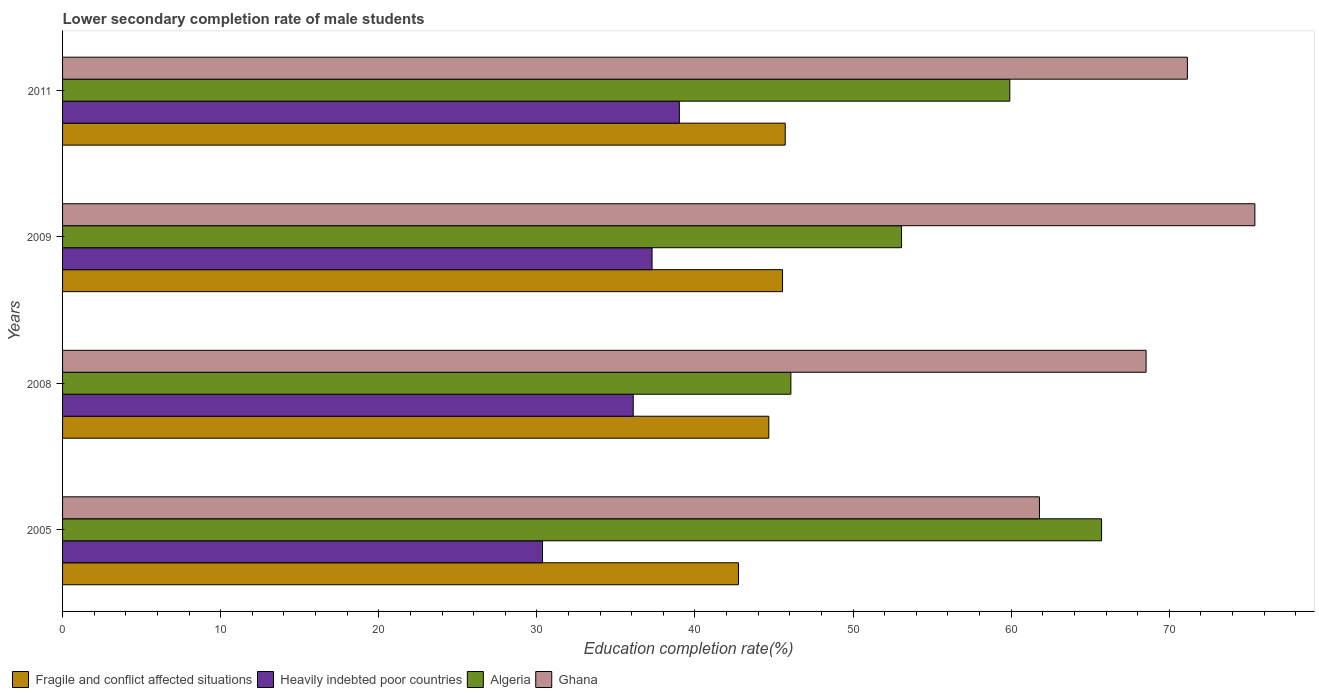How many different coloured bars are there?
Offer a terse response. 4. How many groups of bars are there?
Your answer should be very brief. 4. Are the number of bars per tick equal to the number of legend labels?
Make the answer very short. Yes. Are the number of bars on each tick of the Y-axis equal?
Ensure brevity in your answer.  Yes. How many bars are there on the 2nd tick from the top?
Give a very brief answer. 4. In how many cases, is the number of bars for a given year not equal to the number of legend labels?
Make the answer very short. 0. What is the lower secondary completion rate of male students in Fragile and conflict affected situations in 2005?
Offer a terse response. 42.75. Across all years, what is the maximum lower secondary completion rate of male students in Fragile and conflict affected situations?
Ensure brevity in your answer.  45.71. Across all years, what is the minimum lower secondary completion rate of male students in Algeria?
Offer a very short reply. 46.07. In which year was the lower secondary completion rate of male students in Heavily indebted poor countries minimum?
Provide a short and direct response. 2005. What is the total lower secondary completion rate of male students in Ghana in the graph?
Offer a very short reply. 276.88. What is the difference between the lower secondary completion rate of male students in Algeria in 2005 and that in 2008?
Your answer should be compact. 19.65. What is the difference between the lower secondary completion rate of male students in Heavily indebted poor countries in 2009 and the lower secondary completion rate of male students in Ghana in 2008?
Keep it short and to the point. -31.25. What is the average lower secondary completion rate of male students in Ghana per year?
Offer a very short reply. 69.22. In the year 2008, what is the difference between the lower secondary completion rate of male students in Algeria and lower secondary completion rate of male students in Fragile and conflict affected situations?
Offer a terse response. 1.4. What is the ratio of the lower secondary completion rate of male students in Heavily indebted poor countries in 2009 to that in 2011?
Your answer should be compact. 0.96. Is the lower secondary completion rate of male students in Fragile and conflict affected situations in 2005 less than that in 2009?
Give a very brief answer. Yes. Is the difference between the lower secondary completion rate of male students in Algeria in 2005 and 2009 greater than the difference between the lower secondary completion rate of male students in Fragile and conflict affected situations in 2005 and 2009?
Offer a terse response. Yes. What is the difference between the highest and the second highest lower secondary completion rate of male students in Fragile and conflict affected situations?
Offer a very short reply. 0.17. What is the difference between the highest and the lowest lower secondary completion rate of male students in Heavily indebted poor countries?
Your answer should be compact. 8.66. In how many years, is the lower secondary completion rate of male students in Fragile and conflict affected situations greater than the average lower secondary completion rate of male students in Fragile and conflict affected situations taken over all years?
Ensure brevity in your answer.  3. Is the sum of the lower secondary completion rate of male students in Heavily indebted poor countries in 2005 and 2008 greater than the maximum lower secondary completion rate of male students in Algeria across all years?
Your answer should be compact. Yes. Is it the case that in every year, the sum of the lower secondary completion rate of male students in Algeria and lower secondary completion rate of male students in Heavily indebted poor countries is greater than the sum of lower secondary completion rate of male students in Fragile and conflict affected situations and lower secondary completion rate of male students in Ghana?
Give a very brief answer. No. What does the 1st bar from the top in 2008 represents?
Keep it short and to the point. Ghana. What does the 3rd bar from the bottom in 2011 represents?
Make the answer very short. Algeria. How many bars are there?
Provide a succinct answer. 16. Does the graph contain grids?
Make the answer very short. No. Where does the legend appear in the graph?
Provide a short and direct response. Bottom left. How many legend labels are there?
Provide a short and direct response. 4. What is the title of the graph?
Your response must be concise. Lower secondary completion rate of male students. Does "Honduras" appear as one of the legend labels in the graph?
Give a very brief answer. No. What is the label or title of the X-axis?
Your answer should be very brief. Education completion rate(%). What is the Education completion rate(%) of Fragile and conflict affected situations in 2005?
Give a very brief answer. 42.75. What is the Education completion rate(%) in Heavily indebted poor countries in 2005?
Your answer should be compact. 30.36. What is the Education completion rate(%) of Algeria in 2005?
Your answer should be compact. 65.72. What is the Education completion rate(%) of Ghana in 2005?
Give a very brief answer. 61.79. What is the Education completion rate(%) of Fragile and conflict affected situations in 2008?
Your answer should be compact. 44.67. What is the Education completion rate(%) of Heavily indebted poor countries in 2008?
Give a very brief answer. 36.09. What is the Education completion rate(%) in Algeria in 2008?
Your answer should be very brief. 46.07. What is the Education completion rate(%) of Ghana in 2008?
Give a very brief answer. 68.53. What is the Education completion rate(%) in Fragile and conflict affected situations in 2009?
Offer a very short reply. 45.54. What is the Education completion rate(%) in Heavily indebted poor countries in 2009?
Make the answer very short. 37.29. What is the Education completion rate(%) of Algeria in 2009?
Your answer should be compact. 53.06. What is the Education completion rate(%) of Ghana in 2009?
Give a very brief answer. 75.41. What is the Education completion rate(%) of Fragile and conflict affected situations in 2011?
Give a very brief answer. 45.71. What is the Education completion rate(%) of Heavily indebted poor countries in 2011?
Your response must be concise. 39.01. What is the Education completion rate(%) of Algeria in 2011?
Provide a succinct answer. 59.91. What is the Education completion rate(%) of Ghana in 2011?
Provide a short and direct response. 71.14. Across all years, what is the maximum Education completion rate(%) in Fragile and conflict affected situations?
Your response must be concise. 45.71. Across all years, what is the maximum Education completion rate(%) of Heavily indebted poor countries?
Provide a short and direct response. 39.01. Across all years, what is the maximum Education completion rate(%) of Algeria?
Make the answer very short. 65.72. Across all years, what is the maximum Education completion rate(%) of Ghana?
Provide a short and direct response. 75.41. Across all years, what is the minimum Education completion rate(%) of Fragile and conflict affected situations?
Keep it short and to the point. 42.75. Across all years, what is the minimum Education completion rate(%) in Heavily indebted poor countries?
Your answer should be compact. 30.36. Across all years, what is the minimum Education completion rate(%) in Algeria?
Provide a succinct answer. 46.07. Across all years, what is the minimum Education completion rate(%) in Ghana?
Your response must be concise. 61.79. What is the total Education completion rate(%) in Fragile and conflict affected situations in the graph?
Provide a short and direct response. 178.66. What is the total Education completion rate(%) of Heavily indebted poor countries in the graph?
Your response must be concise. 142.75. What is the total Education completion rate(%) in Algeria in the graph?
Your answer should be compact. 224.76. What is the total Education completion rate(%) in Ghana in the graph?
Provide a succinct answer. 276.88. What is the difference between the Education completion rate(%) of Fragile and conflict affected situations in 2005 and that in 2008?
Provide a short and direct response. -1.92. What is the difference between the Education completion rate(%) in Heavily indebted poor countries in 2005 and that in 2008?
Your answer should be very brief. -5.74. What is the difference between the Education completion rate(%) of Algeria in 2005 and that in 2008?
Ensure brevity in your answer.  19.65. What is the difference between the Education completion rate(%) of Ghana in 2005 and that in 2008?
Offer a very short reply. -6.74. What is the difference between the Education completion rate(%) in Fragile and conflict affected situations in 2005 and that in 2009?
Your answer should be compact. -2.79. What is the difference between the Education completion rate(%) of Heavily indebted poor countries in 2005 and that in 2009?
Your response must be concise. -6.93. What is the difference between the Education completion rate(%) in Algeria in 2005 and that in 2009?
Provide a succinct answer. 12.65. What is the difference between the Education completion rate(%) of Ghana in 2005 and that in 2009?
Your answer should be very brief. -13.62. What is the difference between the Education completion rate(%) of Fragile and conflict affected situations in 2005 and that in 2011?
Make the answer very short. -2.96. What is the difference between the Education completion rate(%) in Heavily indebted poor countries in 2005 and that in 2011?
Your answer should be compact. -8.66. What is the difference between the Education completion rate(%) of Algeria in 2005 and that in 2011?
Provide a succinct answer. 5.8. What is the difference between the Education completion rate(%) of Ghana in 2005 and that in 2011?
Offer a very short reply. -9.36. What is the difference between the Education completion rate(%) in Fragile and conflict affected situations in 2008 and that in 2009?
Ensure brevity in your answer.  -0.87. What is the difference between the Education completion rate(%) of Heavily indebted poor countries in 2008 and that in 2009?
Offer a terse response. -1.19. What is the difference between the Education completion rate(%) of Algeria in 2008 and that in 2009?
Provide a succinct answer. -7. What is the difference between the Education completion rate(%) in Ghana in 2008 and that in 2009?
Your answer should be compact. -6.88. What is the difference between the Education completion rate(%) of Fragile and conflict affected situations in 2008 and that in 2011?
Provide a succinct answer. -1.04. What is the difference between the Education completion rate(%) in Heavily indebted poor countries in 2008 and that in 2011?
Provide a short and direct response. -2.92. What is the difference between the Education completion rate(%) in Algeria in 2008 and that in 2011?
Your response must be concise. -13.85. What is the difference between the Education completion rate(%) of Ghana in 2008 and that in 2011?
Offer a very short reply. -2.61. What is the difference between the Education completion rate(%) in Fragile and conflict affected situations in 2009 and that in 2011?
Keep it short and to the point. -0.17. What is the difference between the Education completion rate(%) in Heavily indebted poor countries in 2009 and that in 2011?
Provide a succinct answer. -1.73. What is the difference between the Education completion rate(%) of Algeria in 2009 and that in 2011?
Offer a very short reply. -6.85. What is the difference between the Education completion rate(%) of Ghana in 2009 and that in 2011?
Your answer should be compact. 4.27. What is the difference between the Education completion rate(%) in Fragile and conflict affected situations in 2005 and the Education completion rate(%) in Heavily indebted poor countries in 2008?
Provide a succinct answer. 6.66. What is the difference between the Education completion rate(%) in Fragile and conflict affected situations in 2005 and the Education completion rate(%) in Algeria in 2008?
Provide a short and direct response. -3.32. What is the difference between the Education completion rate(%) of Fragile and conflict affected situations in 2005 and the Education completion rate(%) of Ghana in 2008?
Provide a short and direct response. -25.78. What is the difference between the Education completion rate(%) of Heavily indebted poor countries in 2005 and the Education completion rate(%) of Algeria in 2008?
Give a very brief answer. -15.71. What is the difference between the Education completion rate(%) in Heavily indebted poor countries in 2005 and the Education completion rate(%) in Ghana in 2008?
Offer a terse response. -38.17. What is the difference between the Education completion rate(%) of Algeria in 2005 and the Education completion rate(%) of Ghana in 2008?
Ensure brevity in your answer.  -2.82. What is the difference between the Education completion rate(%) in Fragile and conflict affected situations in 2005 and the Education completion rate(%) in Heavily indebted poor countries in 2009?
Your answer should be very brief. 5.46. What is the difference between the Education completion rate(%) of Fragile and conflict affected situations in 2005 and the Education completion rate(%) of Algeria in 2009?
Ensure brevity in your answer.  -10.31. What is the difference between the Education completion rate(%) of Fragile and conflict affected situations in 2005 and the Education completion rate(%) of Ghana in 2009?
Keep it short and to the point. -32.66. What is the difference between the Education completion rate(%) in Heavily indebted poor countries in 2005 and the Education completion rate(%) in Algeria in 2009?
Your answer should be compact. -22.71. What is the difference between the Education completion rate(%) in Heavily indebted poor countries in 2005 and the Education completion rate(%) in Ghana in 2009?
Your answer should be compact. -45.06. What is the difference between the Education completion rate(%) in Algeria in 2005 and the Education completion rate(%) in Ghana in 2009?
Provide a succinct answer. -9.7. What is the difference between the Education completion rate(%) in Fragile and conflict affected situations in 2005 and the Education completion rate(%) in Heavily indebted poor countries in 2011?
Your answer should be compact. 3.74. What is the difference between the Education completion rate(%) of Fragile and conflict affected situations in 2005 and the Education completion rate(%) of Algeria in 2011?
Offer a terse response. -17.16. What is the difference between the Education completion rate(%) in Fragile and conflict affected situations in 2005 and the Education completion rate(%) in Ghana in 2011?
Your answer should be compact. -28.39. What is the difference between the Education completion rate(%) in Heavily indebted poor countries in 2005 and the Education completion rate(%) in Algeria in 2011?
Keep it short and to the point. -29.56. What is the difference between the Education completion rate(%) in Heavily indebted poor countries in 2005 and the Education completion rate(%) in Ghana in 2011?
Give a very brief answer. -40.79. What is the difference between the Education completion rate(%) of Algeria in 2005 and the Education completion rate(%) of Ghana in 2011?
Offer a terse response. -5.43. What is the difference between the Education completion rate(%) of Fragile and conflict affected situations in 2008 and the Education completion rate(%) of Heavily indebted poor countries in 2009?
Provide a succinct answer. 7.38. What is the difference between the Education completion rate(%) of Fragile and conflict affected situations in 2008 and the Education completion rate(%) of Algeria in 2009?
Provide a short and direct response. -8.4. What is the difference between the Education completion rate(%) in Fragile and conflict affected situations in 2008 and the Education completion rate(%) in Ghana in 2009?
Your answer should be very brief. -30.74. What is the difference between the Education completion rate(%) of Heavily indebted poor countries in 2008 and the Education completion rate(%) of Algeria in 2009?
Offer a terse response. -16.97. What is the difference between the Education completion rate(%) of Heavily indebted poor countries in 2008 and the Education completion rate(%) of Ghana in 2009?
Provide a succinct answer. -39.32. What is the difference between the Education completion rate(%) of Algeria in 2008 and the Education completion rate(%) of Ghana in 2009?
Your answer should be compact. -29.35. What is the difference between the Education completion rate(%) in Fragile and conflict affected situations in 2008 and the Education completion rate(%) in Heavily indebted poor countries in 2011?
Your response must be concise. 5.66. What is the difference between the Education completion rate(%) in Fragile and conflict affected situations in 2008 and the Education completion rate(%) in Algeria in 2011?
Your response must be concise. -15.24. What is the difference between the Education completion rate(%) in Fragile and conflict affected situations in 2008 and the Education completion rate(%) in Ghana in 2011?
Keep it short and to the point. -26.48. What is the difference between the Education completion rate(%) in Heavily indebted poor countries in 2008 and the Education completion rate(%) in Algeria in 2011?
Provide a succinct answer. -23.82. What is the difference between the Education completion rate(%) in Heavily indebted poor countries in 2008 and the Education completion rate(%) in Ghana in 2011?
Your answer should be very brief. -35.05. What is the difference between the Education completion rate(%) of Algeria in 2008 and the Education completion rate(%) of Ghana in 2011?
Provide a succinct answer. -25.08. What is the difference between the Education completion rate(%) in Fragile and conflict affected situations in 2009 and the Education completion rate(%) in Heavily indebted poor countries in 2011?
Provide a succinct answer. 6.53. What is the difference between the Education completion rate(%) in Fragile and conflict affected situations in 2009 and the Education completion rate(%) in Algeria in 2011?
Provide a short and direct response. -14.37. What is the difference between the Education completion rate(%) of Fragile and conflict affected situations in 2009 and the Education completion rate(%) of Ghana in 2011?
Provide a short and direct response. -25.61. What is the difference between the Education completion rate(%) in Heavily indebted poor countries in 2009 and the Education completion rate(%) in Algeria in 2011?
Offer a terse response. -22.63. What is the difference between the Education completion rate(%) in Heavily indebted poor countries in 2009 and the Education completion rate(%) in Ghana in 2011?
Provide a short and direct response. -33.86. What is the difference between the Education completion rate(%) in Algeria in 2009 and the Education completion rate(%) in Ghana in 2011?
Make the answer very short. -18.08. What is the average Education completion rate(%) in Fragile and conflict affected situations per year?
Provide a succinct answer. 44.67. What is the average Education completion rate(%) in Heavily indebted poor countries per year?
Your response must be concise. 35.69. What is the average Education completion rate(%) of Algeria per year?
Ensure brevity in your answer.  56.19. What is the average Education completion rate(%) in Ghana per year?
Keep it short and to the point. 69.22. In the year 2005, what is the difference between the Education completion rate(%) in Fragile and conflict affected situations and Education completion rate(%) in Heavily indebted poor countries?
Your answer should be very brief. 12.39. In the year 2005, what is the difference between the Education completion rate(%) in Fragile and conflict affected situations and Education completion rate(%) in Algeria?
Make the answer very short. -22.97. In the year 2005, what is the difference between the Education completion rate(%) in Fragile and conflict affected situations and Education completion rate(%) in Ghana?
Ensure brevity in your answer.  -19.04. In the year 2005, what is the difference between the Education completion rate(%) in Heavily indebted poor countries and Education completion rate(%) in Algeria?
Your answer should be very brief. -35.36. In the year 2005, what is the difference between the Education completion rate(%) in Heavily indebted poor countries and Education completion rate(%) in Ghana?
Provide a succinct answer. -31.43. In the year 2005, what is the difference between the Education completion rate(%) of Algeria and Education completion rate(%) of Ghana?
Your answer should be very brief. 3.93. In the year 2008, what is the difference between the Education completion rate(%) in Fragile and conflict affected situations and Education completion rate(%) in Heavily indebted poor countries?
Ensure brevity in your answer.  8.57. In the year 2008, what is the difference between the Education completion rate(%) of Fragile and conflict affected situations and Education completion rate(%) of Algeria?
Your answer should be very brief. -1.4. In the year 2008, what is the difference between the Education completion rate(%) in Fragile and conflict affected situations and Education completion rate(%) in Ghana?
Your answer should be very brief. -23.86. In the year 2008, what is the difference between the Education completion rate(%) of Heavily indebted poor countries and Education completion rate(%) of Algeria?
Your answer should be compact. -9.97. In the year 2008, what is the difference between the Education completion rate(%) of Heavily indebted poor countries and Education completion rate(%) of Ghana?
Make the answer very short. -32.44. In the year 2008, what is the difference between the Education completion rate(%) in Algeria and Education completion rate(%) in Ghana?
Your answer should be compact. -22.47. In the year 2009, what is the difference between the Education completion rate(%) in Fragile and conflict affected situations and Education completion rate(%) in Heavily indebted poor countries?
Give a very brief answer. 8.25. In the year 2009, what is the difference between the Education completion rate(%) in Fragile and conflict affected situations and Education completion rate(%) in Algeria?
Give a very brief answer. -7.53. In the year 2009, what is the difference between the Education completion rate(%) in Fragile and conflict affected situations and Education completion rate(%) in Ghana?
Your answer should be very brief. -29.87. In the year 2009, what is the difference between the Education completion rate(%) in Heavily indebted poor countries and Education completion rate(%) in Algeria?
Make the answer very short. -15.78. In the year 2009, what is the difference between the Education completion rate(%) in Heavily indebted poor countries and Education completion rate(%) in Ghana?
Provide a succinct answer. -38.13. In the year 2009, what is the difference between the Education completion rate(%) in Algeria and Education completion rate(%) in Ghana?
Provide a succinct answer. -22.35. In the year 2011, what is the difference between the Education completion rate(%) in Fragile and conflict affected situations and Education completion rate(%) in Heavily indebted poor countries?
Keep it short and to the point. 6.69. In the year 2011, what is the difference between the Education completion rate(%) of Fragile and conflict affected situations and Education completion rate(%) of Algeria?
Keep it short and to the point. -14.21. In the year 2011, what is the difference between the Education completion rate(%) in Fragile and conflict affected situations and Education completion rate(%) in Ghana?
Your answer should be very brief. -25.44. In the year 2011, what is the difference between the Education completion rate(%) of Heavily indebted poor countries and Education completion rate(%) of Algeria?
Offer a terse response. -20.9. In the year 2011, what is the difference between the Education completion rate(%) in Heavily indebted poor countries and Education completion rate(%) in Ghana?
Offer a very short reply. -32.13. In the year 2011, what is the difference between the Education completion rate(%) of Algeria and Education completion rate(%) of Ghana?
Ensure brevity in your answer.  -11.23. What is the ratio of the Education completion rate(%) of Fragile and conflict affected situations in 2005 to that in 2008?
Offer a terse response. 0.96. What is the ratio of the Education completion rate(%) of Heavily indebted poor countries in 2005 to that in 2008?
Provide a succinct answer. 0.84. What is the ratio of the Education completion rate(%) of Algeria in 2005 to that in 2008?
Ensure brevity in your answer.  1.43. What is the ratio of the Education completion rate(%) in Ghana in 2005 to that in 2008?
Offer a terse response. 0.9. What is the ratio of the Education completion rate(%) in Fragile and conflict affected situations in 2005 to that in 2009?
Provide a short and direct response. 0.94. What is the ratio of the Education completion rate(%) in Heavily indebted poor countries in 2005 to that in 2009?
Ensure brevity in your answer.  0.81. What is the ratio of the Education completion rate(%) in Algeria in 2005 to that in 2009?
Make the answer very short. 1.24. What is the ratio of the Education completion rate(%) in Ghana in 2005 to that in 2009?
Your answer should be very brief. 0.82. What is the ratio of the Education completion rate(%) in Fragile and conflict affected situations in 2005 to that in 2011?
Your response must be concise. 0.94. What is the ratio of the Education completion rate(%) in Heavily indebted poor countries in 2005 to that in 2011?
Provide a succinct answer. 0.78. What is the ratio of the Education completion rate(%) in Algeria in 2005 to that in 2011?
Make the answer very short. 1.1. What is the ratio of the Education completion rate(%) of Ghana in 2005 to that in 2011?
Keep it short and to the point. 0.87. What is the ratio of the Education completion rate(%) of Fragile and conflict affected situations in 2008 to that in 2009?
Your answer should be compact. 0.98. What is the ratio of the Education completion rate(%) of Algeria in 2008 to that in 2009?
Provide a succinct answer. 0.87. What is the ratio of the Education completion rate(%) of Ghana in 2008 to that in 2009?
Ensure brevity in your answer.  0.91. What is the ratio of the Education completion rate(%) of Fragile and conflict affected situations in 2008 to that in 2011?
Keep it short and to the point. 0.98. What is the ratio of the Education completion rate(%) of Heavily indebted poor countries in 2008 to that in 2011?
Provide a succinct answer. 0.93. What is the ratio of the Education completion rate(%) in Algeria in 2008 to that in 2011?
Make the answer very short. 0.77. What is the ratio of the Education completion rate(%) in Ghana in 2008 to that in 2011?
Your answer should be compact. 0.96. What is the ratio of the Education completion rate(%) in Heavily indebted poor countries in 2009 to that in 2011?
Your answer should be very brief. 0.96. What is the ratio of the Education completion rate(%) of Algeria in 2009 to that in 2011?
Your answer should be very brief. 0.89. What is the ratio of the Education completion rate(%) of Ghana in 2009 to that in 2011?
Provide a succinct answer. 1.06. What is the difference between the highest and the second highest Education completion rate(%) of Fragile and conflict affected situations?
Your answer should be compact. 0.17. What is the difference between the highest and the second highest Education completion rate(%) of Heavily indebted poor countries?
Your answer should be compact. 1.73. What is the difference between the highest and the second highest Education completion rate(%) in Algeria?
Provide a short and direct response. 5.8. What is the difference between the highest and the second highest Education completion rate(%) of Ghana?
Keep it short and to the point. 4.27. What is the difference between the highest and the lowest Education completion rate(%) of Fragile and conflict affected situations?
Make the answer very short. 2.96. What is the difference between the highest and the lowest Education completion rate(%) of Heavily indebted poor countries?
Your response must be concise. 8.66. What is the difference between the highest and the lowest Education completion rate(%) in Algeria?
Keep it short and to the point. 19.65. What is the difference between the highest and the lowest Education completion rate(%) in Ghana?
Keep it short and to the point. 13.62. 